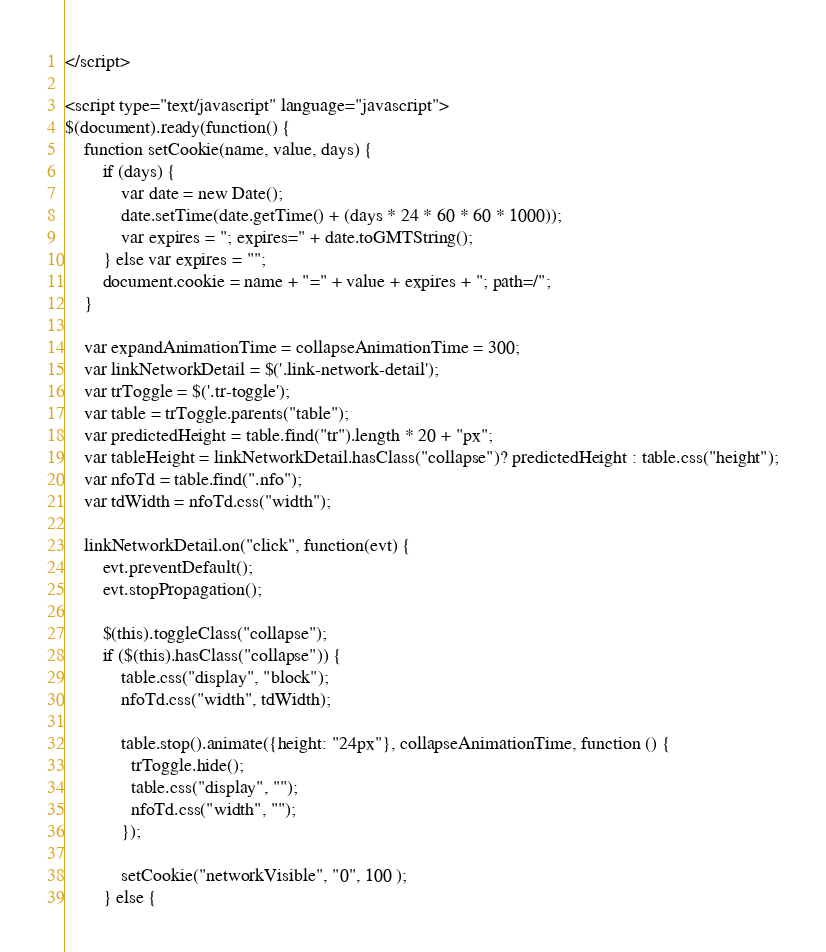<code> <loc_0><loc_0><loc_500><loc_500><_PHP_></script>

<script type="text/javascript" language="javascript">
$(document).ready(function() {
    function setCookie(name, value, days) {
        if (days) {
            var date = new Date();
            date.setTime(date.getTime() + (days * 24 * 60 * 60 * 1000));
            var expires = "; expires=" + date.toGMTString();
        } else var expires = "";
        document.cookie = name + "=" + value + expires + "; path=/";
    }

    var expandAnimationTime = collapseAnimationTime = 300;
    var linkNetworkDetail = $('.link-network-detail');
    var trToggle = $('.tr-toggle');
    var table = trToggle.parents("table");
    var predictedHeight = table.find("tr").length * 20 + "px";
    var tableHeight = linkNetworkDetail.hasClass("collapse")? predictedHeight : table.css("height");
    var nfoTd = table.find(".nfo");
    var tdWidth = nfoTd.css("width");

    linkNetworkDetail.on("click", function(evt) {
        evt.preventDefault();
        evt.stopPropagation();

        $(this).toggleClass("collapse");
        if ($(this).hasClass("collapse")) {
            table.css("display", "block");
            nfoTd.css("width", tdWidth);

            table.stop().animate({height: "24px"}, collapseAnimationTime, function () {
              trToggle.hide();
              table.css("display", "");
              nfoTd.css("width", "");
            });

            setCookie("networkVisible", "0", 100 );
        } else {</code> 